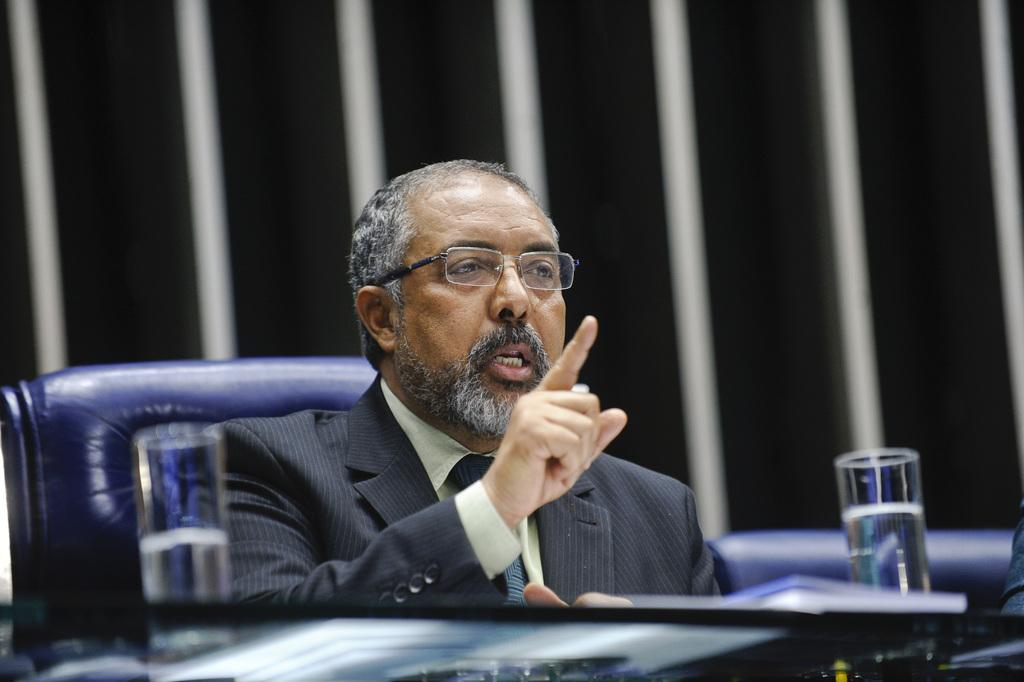What type of furniture can be seen in the image? There are chairs in the image. Is anyone using the chairs in the image? Yes, a person is sitting on a chair. What can be seen in the glasses in the image? There are glasses in the image, but it is not clear what they contain. What is visible in the image that is not furniture or glasses? There are objects in the image. Can you describe the background of the image? The background of the image is blurry. What type of picture is hanging on the door in the image? There is no door or picture present in the image. What type of coach is visible in the image? There is no coach present in the image. 